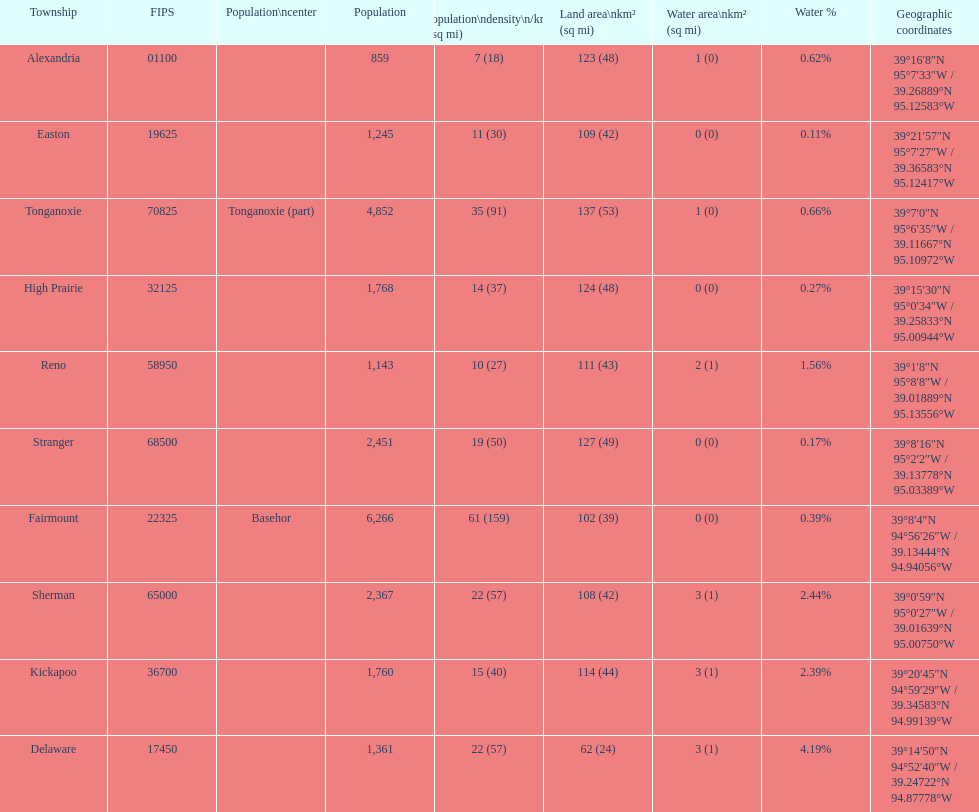What township has the most land area? Tonganoxie. 